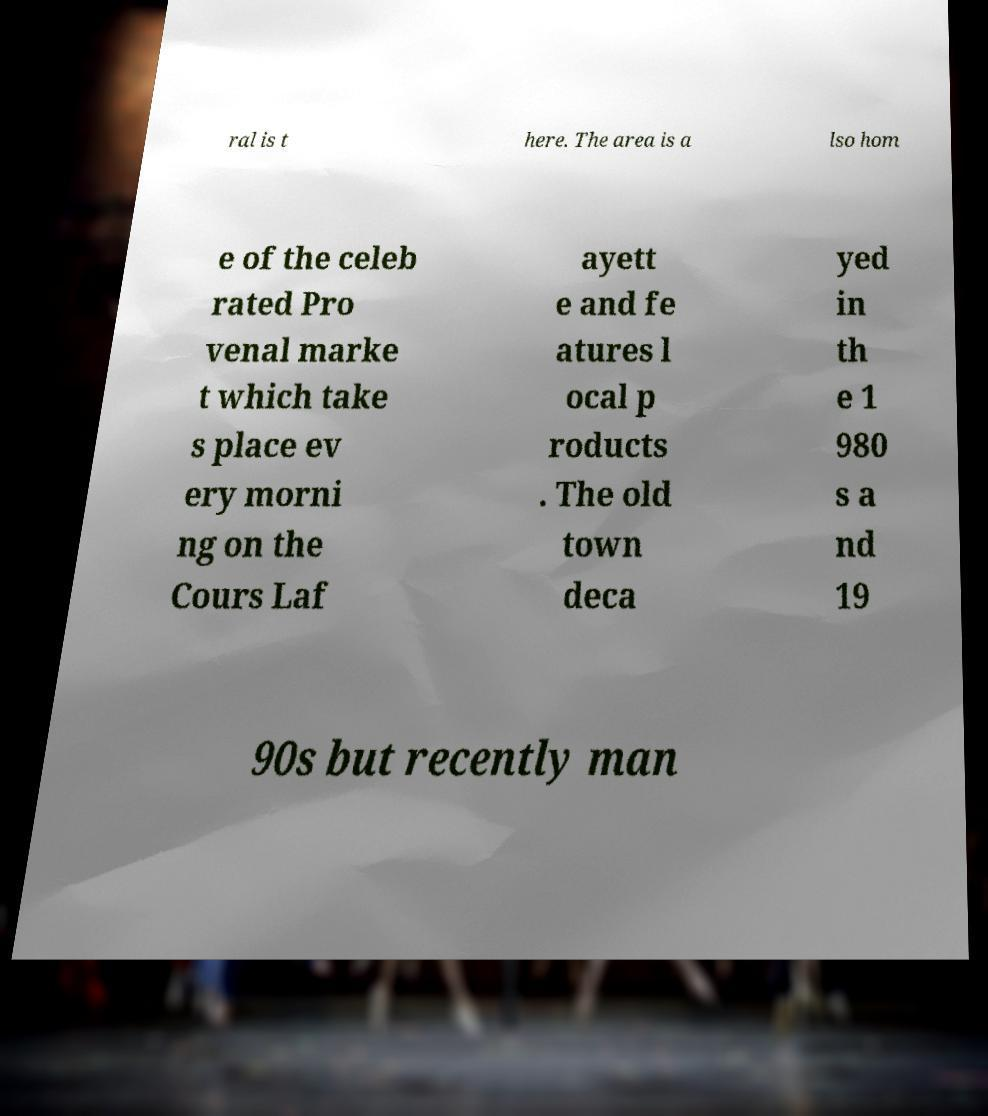There's text embedded in this image that I need extracted. Can you transcribe it verbatim? ral is t here. The area is a lso hom e of the celeb rated Pro venal marke t which take s place ev ery morni ng on the Cours Laf ayett e and fe atures l ocal p roducts . The old town deca yed in th e 1 980 s a nd 19 90s but recently man 